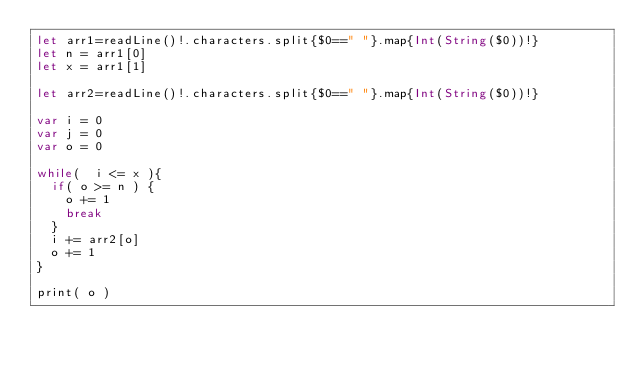Convert code to text. <code><loc_0><loc_0><loc_500><loc_500><_Swift_>let arr1=readLine()!.characters.split{$0==" "}.map{Int(String($0))!}
let n = arr1[0]
let x = arr1[1]

let arr2=readLine()!.characters.split{$0==" "}.map{Int(String($0))!}

var i = 0
var j = 0
var o = 0

while(  i <= x ){
  if( o >= n ) {
    o += 1 
    break
  }
  i += arr2[o]
  o += 1
}

print( o )
</code> 